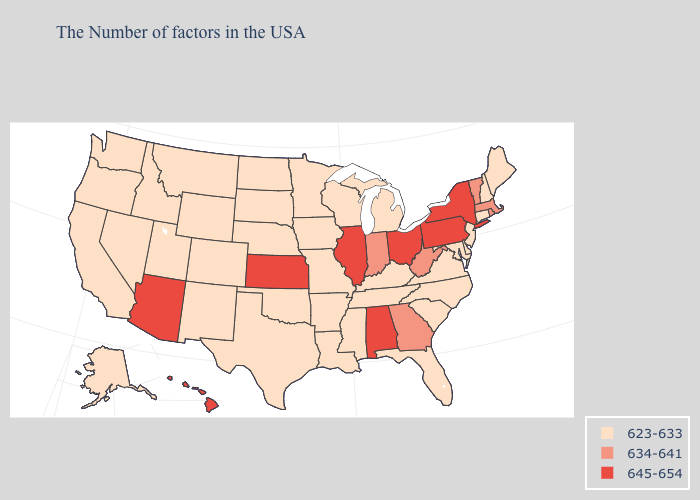What is the lowest value in states that border Connecticut?
Write a very short answer. 634-641. Name the states that have a value in the range 623-633?
Give a very brief answer. Maine, New Hampshire, Connecticut, New Jersey, Delaware, Maryland, Virginia, North Carolina, South Carolina, Florida, Michigan, Kentucky, Tennessee, Wisconsin, Mississippi, Louisiana, Missouri, Arkansas, Minnesota, Iowa, Nebraska, Oklahoma, Texas, South Dakota, North Dakota, Wyoming, Colorado, New Mexico, Utah, Montana, Idaho, Nevada, California, Washington, Oregon, Alaska. Among the states that border California , which have the highest value?
Give a very brief answer. Arizona. Does Arkansas have the lowest value in the South?
Keep it brief. Yes. What is the highest value in the West ?
Write a very short answer. 645-654. Does West Virginia have a lower value than Ohio?
Short answer required. Yes. What is the value of Utah?
Write a very short answer. 623-633. Does the first symbol in the legend represent the smallest category?
Keep it brief. Yes. Does Massachusetts have the lowest value in the Northeast?
Keep it brief. No. Name the states that have a value in the range 645-654?
Answer briefly. New York, Pennsylvania, Ohio, Alabama, Illinois, Kansas, Arizona, Hawaii. Does South Carolina have the same value as Colorado?
Be succinct. Yes. Among the states that border Massachusetts , does Rhode Island have the lowest value?
Quick response, please. No. What is the value of Delaware?
Answer briefly. 623-633. What is the value of Alabama?
Give a very brief answer. 645-654. What is the highest value in the MidWest ?
Give a very brief answer. 645-654. 